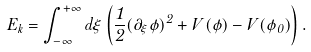Convert formula to latex. <formula><loc_0><loc_0><loc_500><loc_500>E _ { k } = \int _ { - \infty } ^ { + \infty } d \xi \left ( \frac { 1 } { 2 } ( \partial _ { \xi } \phi ) ^ { 2 } + V ( \phi ) - V ( \phi _ { 0 } ) \right ) .</formula> 